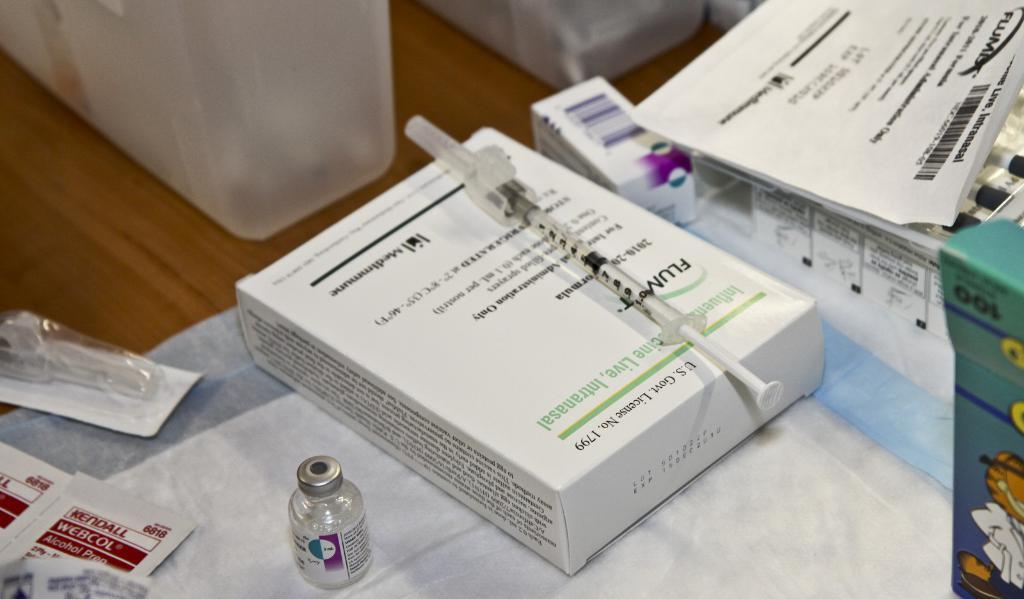<image>
Describe the image concisely. a medical table has WEBCOL alcohol prep wipes and a syringe of something 